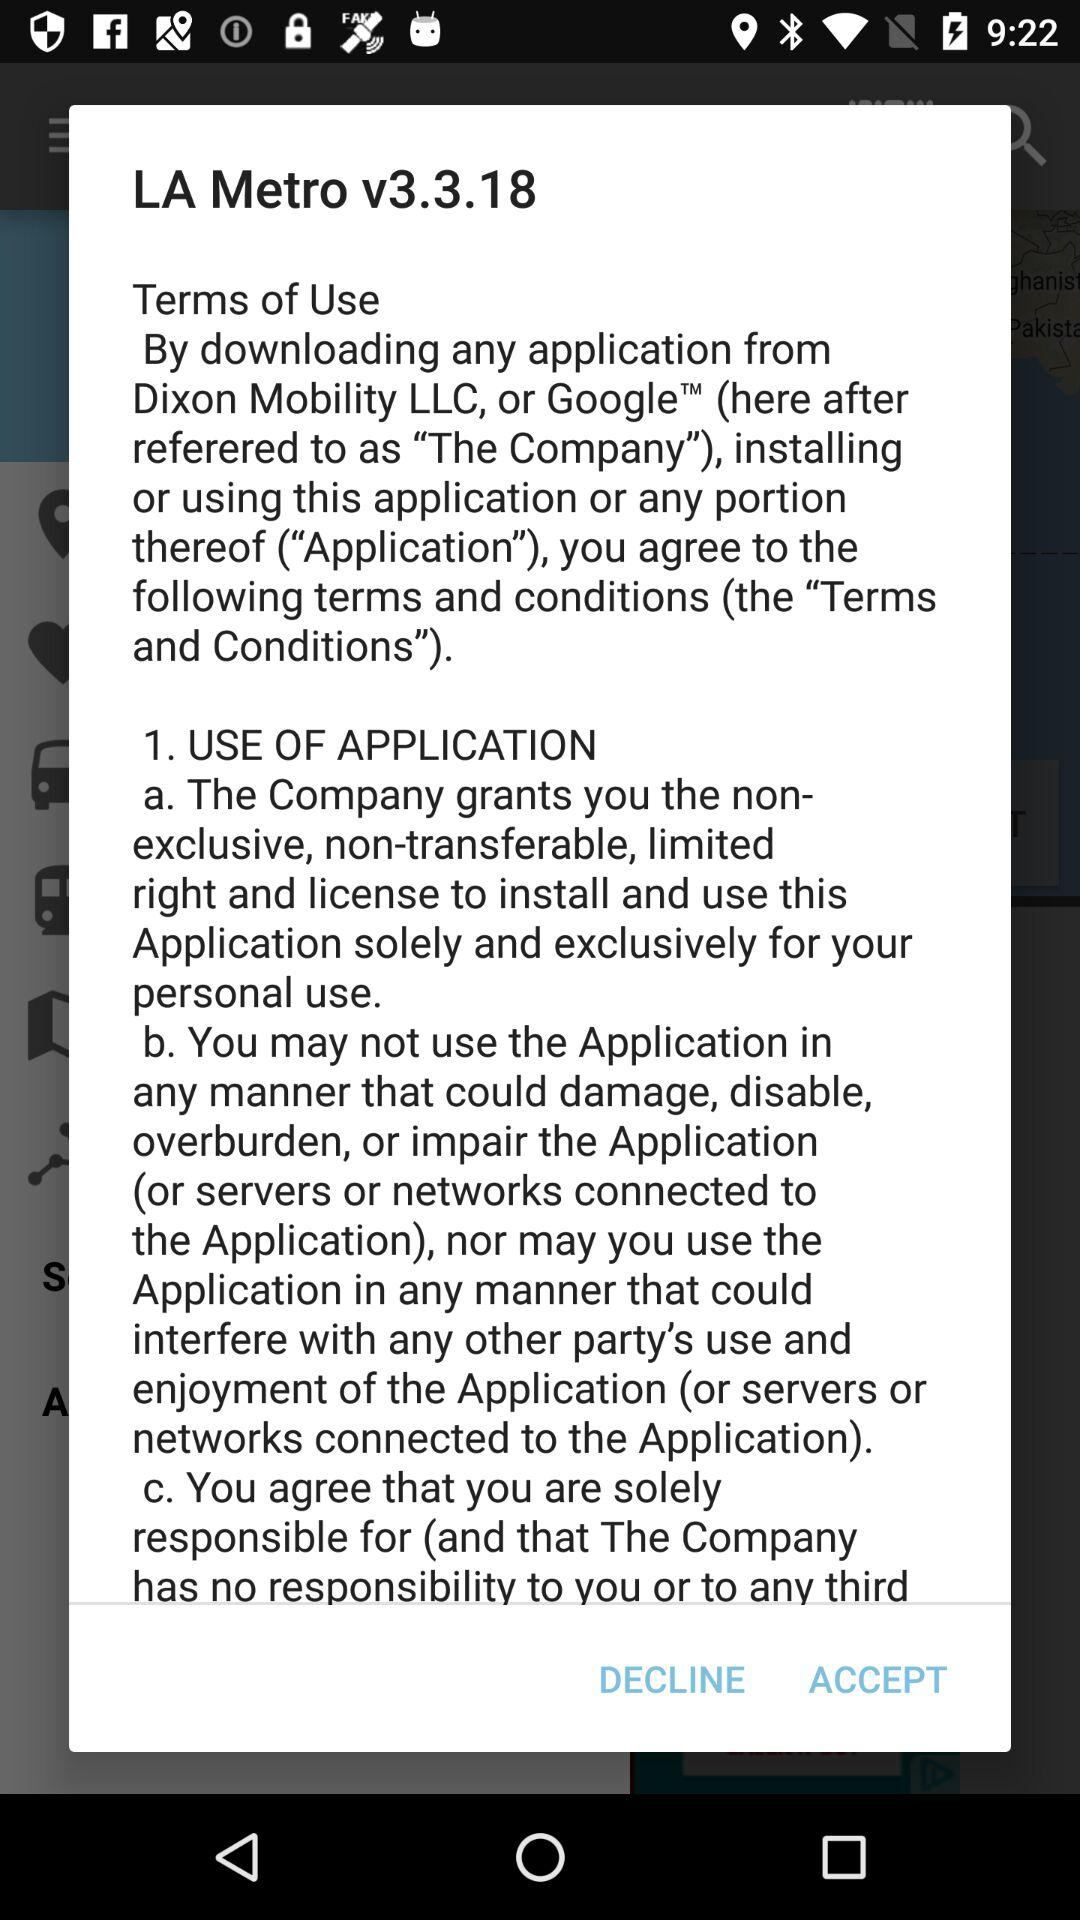What is the version number? The version number is v3.3.18. 